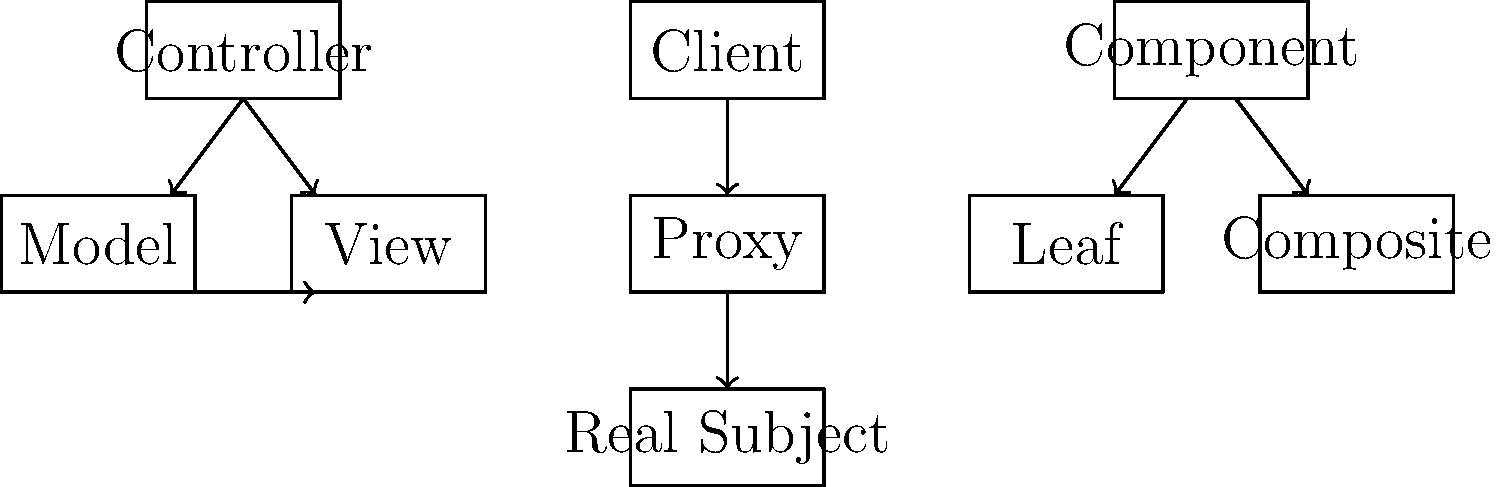Match the UML diagrams labeled A, B, and C to their corresponding software architecture patterns: Model-View-Controller (MVC), Proxy, and Composite. Which pattern corresponds to each diagram? Let's analyze each diagram to identify the corresponding software architecture pattern:

1. Diagram A:
   - Shows three main components: Controller, Model, and View
   - Controller interacts with both Model and View
   - Model and View have a bidirectional relationship
   This structure clearly represents the Model-View-Controller (MVC) pattern, where the Controller manages the flow between Model (data) and View (user interface).

2. Diagram B:
   - Depicts a Client, Proxy, and Real Subject
   - Client interacts with Proxy, which in turn interacts with Real Subject
   - This linear structure represents the Proxy pattern, where Proxy acts as a surrogate for Real Subject, controlling access to it.

3. Diagram C:
   - Shows a Component at the top, with Leaf and Composite below
   - Both Leaf and Composite are connected to Component
   This tree-like structure represents the Composite pattern, where individual objects (Leaf) and compositions of objects (Composite) are treated uniformly through a common Component interface.

Therefore, the matching is as follows:
A - Model-View-Controller (MVC)
B - Proxy
C - Composite
Answer: A: MVC, B: Proxy, C: Composite 